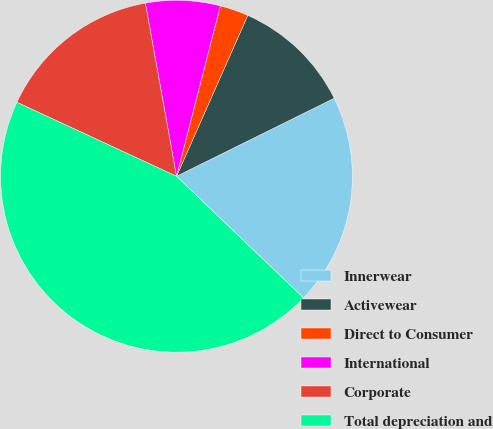Convert chart. <chart><loc_0><loc_0><loc_500><loc_500><pie_chart><fcel>Innerwear<fcel>Activewear<fcel>Direct to Consumer<fcel>International<fcel>Corporate<fcel>Total depreciation and<nl><fcel>19.47%<fcel>11.05%<fcel>2.63%<fcel>6.84%<fcel>15.26%<fcel>44.74%<nl></chart> 